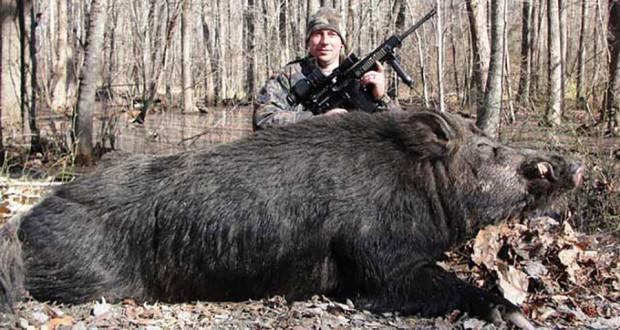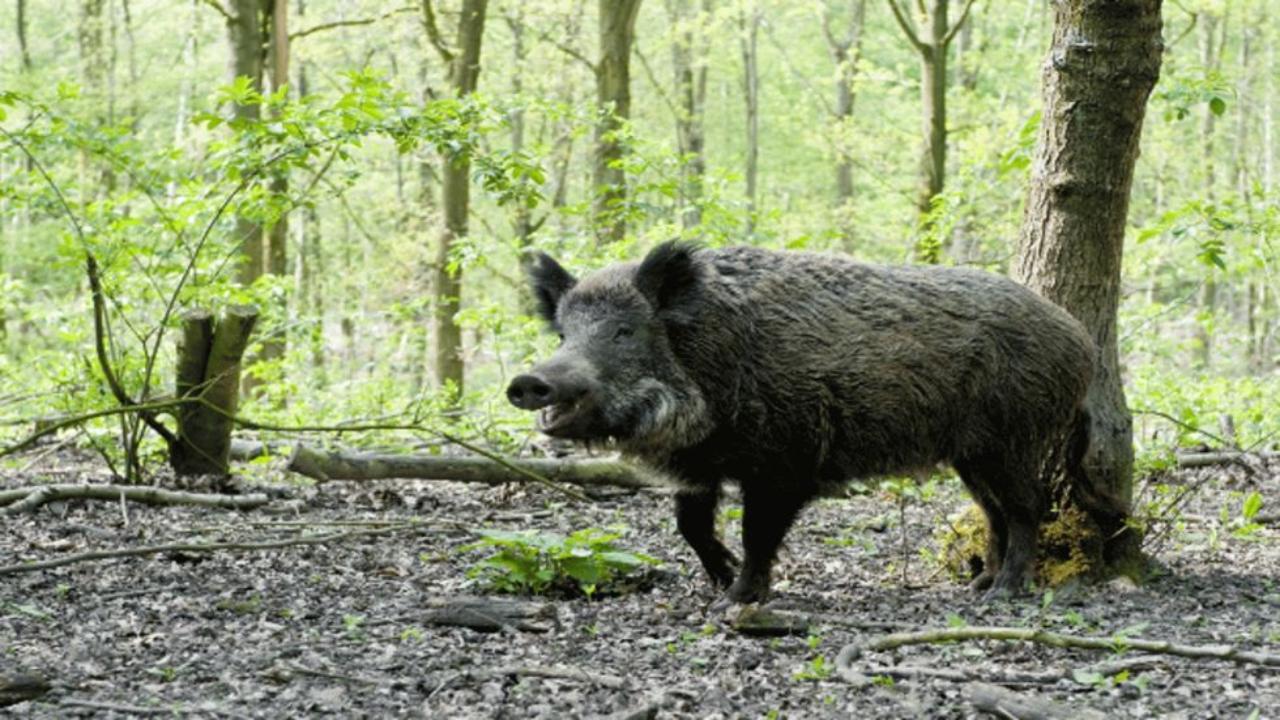The first image is the image on the left, the second image is the image on the right. Given the left and right images, does the statement "In one of the image there are baby pigs near a mother pig" hold true? Answer yes or no. No. The first image is the image on the left, the second image is the image on the right. Assess this claim about the two images: "There is at least two boars in the left image.". Correct or not? Answer yes or no. No. 